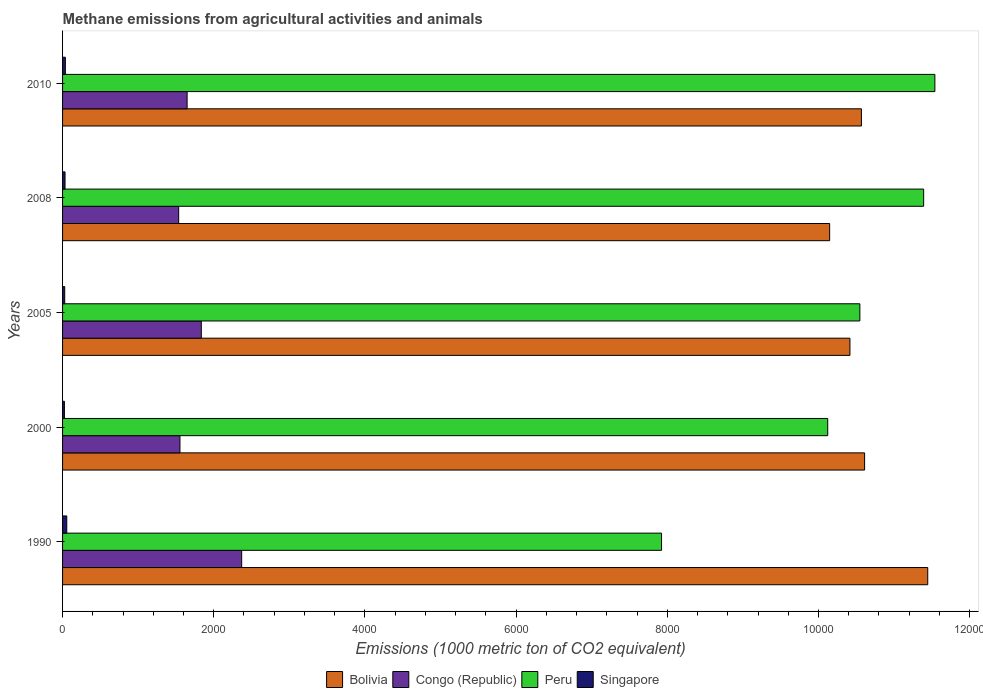How many different coloured bars are there?
Ensure brevity in your answer.  4. How many groups of bars are there?
Offer a very short reply. 5. How many bars are there on the 5th tick from the top?
Offer a terse response. 4. What is the label of the 5th group of bars from the top?
Keep it short and to the point. 1990. In how many cases, is the number of bars for a given year not equal to the number of legend labels?
Offer a very short reply. 0. What is the amount of methane emitted in Peru in 2000?
Offer a very short reply. 1.01e+04. Across all years, what is the maximum amount of methane emitted in Singapore?
Your answer should be very brief. 55.6. Across all years, what is the minimum amount of methane emitted in Singapore?
Offer a very short reply. 24.4. In which year was the amount of methane emitted in Congo (Republic) minimum?
Your response must be concise. 2008. What is the total amount of methane emitted in Singapore in the graph?
Keep it short and to the point. 178.1. What is the difference between the amount of methane emitted in Singapore in 1990 and that in 2000?
Your answer should be very brief. 31.2. What is the difference between the amount of methane emitted in Congo (Republic) in 2010 and the amount of methane emitted in Singapore in 2000?
Give a very brief answer. 1623.2. What is the average amount of methane emitted in Bolivia per year?
Keep it short and to the point. 1.06e+04. In the year 2010, what is the difference between the amount of methane emitted in Peru and amount of methane emitted in Congo (Republic)?
Your answer should be very brief. 9891.8. In how many years, is the amount of methane emitted in Peru greater than 2000 1000 metric ton?
Ensure brevity in your answer.  5. What is the ratio of the amount of methane emitted in Singapore in 2005 to that in 2010?
Keep it short and to the point. 0.77. Is the amount of methane emitted in Singapore in 1990 less than that in 2010?
Your answer should be very brief. No. Is the difference between the amount of methane emitted in Peru in 2000 and 2005 greater than the difference between the amount of methane emitted in Congo (Republic) in 2000 and 2005?
Ensure brevity in your answer.  No. What is the difference between the highest and the second highest amount of methane emitted in Peru?
Ensure brevity in your answer.  148.4. What is the difference between the highest and the lowest amount of methane emitted in Peru?
Ensure brevity in your answer.  3615.7. In how many years, is the amount of methane emitted in Peru greater than the average amount of methane emitted in Peru taken over all years?
Offer a very short reply. 3. Is the sum of the amount of methane emitted in Peru in 2005 and 2008 greater than the maximum amount of methane emitted in Singapore across all years?
Provide a succinct answer. Yes. Is it the case that in every year, the sum of the amount of methane emitted in Congo (Republic) and amount of methane emitted in Singapore is greater than the sum of amount of methane emitted in Peru and amount of methane emitted in Bolivia?
Your answer should be compact. No. What does the 1st bar from the top in 2010 represents?
Offer a very short reply. Singapore. What does the 2nd bar from the bottom in 2000 represents?
Offer a very short reply. Congo (Republic). Is it the case that in every year, the sum of the amount of methane emitted in Singapore and amount of methane emitted in Bolivia is greater than the amount of methane emitted in Peru?
Your answer should be very brief. No. How many bars are there?
Offer a very short reply. 20. Are all the bars in the graph horizontal?
Keep it short and to the point. Yes. Does the graph contain any zero values?
Provide a succinct answer. No. Does the graph contain grids?
Your response must be concise. No. Where does the legend appear in the graph?
Provide a short and direct response. Bottom center. How are the legend labels stacked?
Offer a very short reply. Horizontal. What is the title of the graph?
Provide a succinct answer. Methane emissions from agricultural activities and animals. What is the label or title of the X-axis?
Offer a very short reply. Emissions (1000 metric ton of CO2 equivalent). What is the Emissions (1000 metric ton of CO2 equivalent) in Bolivia in 1990?
Your answer should be compact. 1.14e+04. What is the Emissions (1000 metric ton of CO2 equivalent) in Congo (Republic) in 1990?
Your response must be concise. 2369.4. What is the Emissions (1000 metric ton of CO2 equivalent) in Peru in 1990?
Offer a terse response. 7923.7. What is the Emissions (1000 metric ton of CO2 equivalent) in Singapore in 1990?
Offer a very short reply. 55.6. What is the Emissions (1000 metric ton of CO2 equivalent) in Bolivia in 2000?
Give a very brief answer. 1.06e+04. What is the Emissions (1000 metric ton of CO2 equivalent) of Congo (Republic) in 2000?
Ensure brevity in your answer.  1552.9. What is the Emissions (1000 metric ton of CO2 equivalent) in Peru in 2000?
Provide a succinct answer. 1.01e+04. What is the Emissions (1000 metric ton of CO2 equivalent) in Singapore in 2000?
Provide a short and direct response. 24.4. What is the Emissions (1000 metric ton of CO2 equivalent) of Bolivia in 2005?
Offer a terse response. 1.04e+04. What is the Emissions (1000 metric ton of CO2 equivalent) of Congo (Republic) in 2005?
Your response must be concise. 1835.4. What is the Emissions (1000 metric ton of CO2 equivalent) of Peru in 2005?
Give a very brief answer. 1.05e+04. What is the Emissions (1000 metric ton of CO2 equivalent) in Singapore in 2005?
Your response must be concise. 28.4. What is the Emissions (1000 metric ton of CO2 equivalent) of Bolivia in 2008?
Offer a very short reply. 1.01e+04. What is the Emissions (1000 metric ton of CO2 equivalent) of Congo (Republic) in 2008?
Offer a very short reply. 1535.9. What is the Emissions (1000 metric ton of CO2 equivalent) in Peru in 2008?
Your answer should be compact. 1.14e+04. What is the Emissions (1000 metric ton of CO2 equivalent) of Singapore in 2008?
Keep it short and to the point. 32.8. What is the Emissions (1000 metric ton of CO2 equivalent) of Bolivia in 2010?
Your answer should be very brief. 1.06e+04. What is the Emissions (1000 metric ton of CO2 equivalent) in Congo (Republic) in 2010?
Provide a succinct answer. 1647.6. What is the Emissions (1000 metric ton of CO2 equivalent) in Peru in 2010?
Ensure brevity in your answer.  1.15e+04. What is the Emissions (1000 metric ton of CO2 equivalent) in Singapore in 2010?
Make the answer very short. 36.9. Across all years, what is the maximum Emissions (1000 metric ton of CO2 equivalent) in Bolivia?
Your response must be concise. 1.14e+04. Across all years, what is the maximum Emissions (1000 metric ton of CO2 equivalent) of Congo (Republic)?
Keep it short and to the point. 2369.4. Across all years, what is the maximum Emissions (1000 metric ton of CO2 equivalent) of Peru?
Provide a short and direct response. 1.15e+04. Across all years, what is the maximum Emissions (1000 metric ton of CO2 equivalent) of Singapore?
Keep it short and to the point. 55.6. Across all years, what is the minimum Emissions (1000 metric ton of CO2 equivalent) of Bolivia?
Your answer should be compact. 1.01e+04. Across all years, what is the minimum Emissions (1000 metric ton of CO2 equivalent) in Congo (Republic)?
Ensure brevity in your answer.  1535.9. Across all years, what is the minimum Emissions (1000 metric ton of CO2 equivalent) in Peru?
Offer a very short reply. 7923.7. Across all years, what is the minimum Emissions (1000 metric ton of CO2 equivalent) in Singapore?
Give a very brief answer. 24.4. What is the total Emissions (1000 metric ton of CO2 equivalent) of Bolivia in the graph?
Give a very brief answer. 5.32e+04. What is the total Emissions (1000 metric ton of CO2 equivalent) of Congo (Republic) in the graph?
Keep it short and to the point. 8941.2. What is the total Emissions (1000 metric ton of CO2 equivalent) of Peru in the graph?
Offer a very short reply. 5.15e+04. What is the total Emissions (1000 metric ton of CO2 equivalent) in Singapore in the graph?
Your answer should be compact. 178.1. What is the difference between the Emissions (1000 metric ton of CO2 equivalent) of Bolivia in 1990 and that in 2000?
Keep it short and to the point. 835.3. What is the difference between the Emissions (1000 metric ton of CO2 equivalent) in Congo (Republic) in 1990 and that in 2000?
Your answer should be compact. 816.5. What is the difference between the Emissions (1000 metric ton of CO2 equivalent) of Peru in 1990 and that in 2000?
Offer a very short reply. -2198.2. What is the difference between the Emissions (1000 metric ton of CO2 equivalent) in Singapore in 1990 and that in 2000?
Offer a very short reply. 31.2. What is the difference between the Emissions (1000 metric ton of CO2 equivalent) in Bolivia in 1990 and that in 2005?
Your answer should be compact. 1029.2. What is the difference between the Emissions (1000 metric ton of CO2 equivalent) of Congo (Republic) in 1990 and that in 2005?
Give a very brief answer. 534. What is the difference between the Emissions (1000 metric ton of CO2 equivalent) in Peru in 1990 and that in 2005?
Give a very brief answer. -2623.4. What is the difference between the Emissions (1000 metric ton of CO2 equivalent) in Singapore in 1990 and that in 2005?
Keep it short and to the point. 27.2. What is the difference between the Emissions (1000 metric ton of CO2 equivalent) in Bolivia in 1990 and that in 2008?
Make the answer very short. 1297.5. What is the difference between the Emissions (1000 metric ton of CO2 equivalent) in Congo (Republic) in 1990 and that in 2008?
Provide a short and direct response. 833.5. What is the difference between the Emissions (1000 metric ton of CO2 equivalent) of Peru in 1990 and that in 2008?
Provide a short and direct response. -3467.3. What is the difference between the Emissions (1000 metric ton of CO2 equivalent) of Singapore in 1990 and that in 2008?
Ensure brevity in your answer.  22.8. What is the difference between the Emissions (1000 metric ton of CO2 equivalent) in Bolivia in 1990 and that in 2010?
Provide a short and direct response. 877.3. What is the difference between the Emissions (1000 metric ton of CO2 equivalent) in Congo (Republic) in 1990 and that in 2010?
Provide a succinct answer. 721.8. What is the difference between the Emissions (1000 metric ton of CO2 equivalent) of Peru in 1990 and that in 2010?
Your answer should be compact. -3615.7. What is the difference between the Emissions (1000 metric ton of CO2 equivalent) of Singapore in 1990 and that in 2010?
Provide a short and direct response. 18.7. What is the difference between the Emissions (1000 metric ton of CO2 equivalent) in Bolivia in 2000 and that in 2005?
Your answer should be compact. 193.9. What is the difference between the Emissions (1000 metric ton of CO2 equivalent) of Congo (Republic) in 2000 and that in 2005?
Keep it short and to the point. -282.5. What is the difference between the Emissions (1000 metric ton of CO2 equivalent) of Peru in 2000 and that in 2005?
Provide a short and direct response. -425.2. What is the difference between the Emissions (1000 metric ton of CO2 equivalent) in Bolivia in 2000 and that in 2008?
Your answer should be compact. 462.2. What is the difference between the Emissions (1000 metric ton of CO2 equivalent) of Peru in 2000 and that in 2008?
Provide a short and direct response. -1269.1. What is the difference between the Emissions (1000 metric ton of CO2 equivalent) of Bolivia in 2000 and that in 2010?
Your answer should be compact. 42. What is the difference between the Emissions (1000 metric ton of CO2 equivalent) of Congo (Republic) in 2000 and that in 2010?
Your response must be concise. -94.7. What is the difference between the Emissions (1000 metric ton of CO2 equivalent) of Peru in 2000 and that in 2010?
Your answer should be very brief. -1417.5. What is the difference between the Emissions (1000 metric ton of CO2 equivalent) in Bolivia in 2005 and that in 2008?
Provide a short and direct response. 268.3. What is the difference between the Emissions (1000 metric ton of CO2 equivalent) of Congo (Republic) in 2005 and that in 2008?
Keep it short and to the point. 299.5. What is the difference between the Emissions (1000 metric ton of CO2 equivalent) of Peru in 2005 and that in 2008?
Offer a terse response. -843.9. What is the difference between the Emissions (1000 metric ton of CO2 equivalent) of Bolivia in 2005 and that in 2010?
Make the answer very short. -151.9. What is the difference between the Emissions (1000 metric ton of CO2 equivalent) of Congo (Republic) in 2005 and that in 2010?
Your response must be concise. 187.8. What is the difference between the Emissions (1000 metric ton of CO2 equivalent) of Peru in 2005 and that in 2010?
Provide a short and direct response. -992.3. What is the difference between the Emissions (1000 metric ton of CO2 equivalent) of Singapore in 2005 and that in 2010?
Ensure brevity in your answer.  -8.5. What is the difference between the Emissions (1000 metric ton of CO2 equivalent) in Bolivia in 2008 and that in 2010?
Make the answer very short. -420.2. What is the difference between the Emissions (1000 metric ton of CO2 equivalent) of Congo (Republic) in 2008 and that in 2010?
Keep it short and to the point. -111.7. What is the difference between the Emissions (1000 metric ton of CO2 equivalent) of Peru in 2008 and that in 2010?
Your answer should be compact. -148.4. What is the difference between the Emissions (1000 metric ton of CO2 equivalent) in Bolivia in 1990 and the Emissions (1000 metric ton of CO2 equivalent) in Congo (Republic) in 2000?
Provide a succinct answer. 9892.1. What is the difference between the Emissions (1000 metric ton of CO2 equivalent) in Bolivia in 1990 and the Emissions (1000 metric ton of CO2 equivalent) in Peru in 2000?
Offer a terse response. 1323.1. What is the difference between the Emissions (1000 metric ton of CO2 equivalent) of Bolivia in 1990 and the Emissions (1000 metric ton of CO2 equivalent) of Singapore in 2000?
Give a very brief answer. 1.14e+04. What is the difference between the Emissions (1000 metric ton of CO2 equivalent) of Congo (Republic) in 1990 and the Emissions (1000 metric ton of CO2 equivalent) of Peru in 2000?
Offer a terse response. -7752.5. What is the difference between the Emissions (1000 metric ton of CO2 equivalent) of Congo (Republic) in 1990 and the Emissions (1000 metric ton of CO2 equivalent) of Singapore in 2000?
Offer a terse response. 2345. What is the difference between the Emissions (1000 metric ton of CO2 equivalent) in Peru in 1990 and the Emissions (1000 metric ton of CO2 equivalent) in Singapore in 2000?
Offer a very short reply. 7899.3. What is the difference between the Emissions (1000 metric ton of CO2 equivalent) of Bolivia in 1990 and the Emissions (1000 metric ton of CO2 equivalent) of Congo (Republic) in 2005?
Your answer should be compact. 9609.6. What is the difference between the Emissions (1000 metric ton of CO2 equivalent) of Bolivia in 1990 and the Emissions (1000 metric ton of CO2 equivalent) of Peru in 2005?
Your answer should be compact. 897.9. What is the difference between the Emissions (1000 metric ton of CO2 equivalent) in Bolivia in 1990 and the Emissions (1000 metric ton of CO2 equivalent) in Singapore in 2005?
Offer a very short reply. 1.14e+04. What is the difference between the Emissions (1000 metric ton of CO2 equivalent) in Congo (Republic) in 1990 and the Emissions (1000 metric ton of CO2 equivalent) in Peru in 2005?
Your answer should be very brief. -8177.7. What is the difference between the Emissions (1000 metric ton of CO2 equivalent) in Congo (Republic) in 1990 and the Emissions (1000 metric ton of CO2 equivalent) in Singapore in 2005?
Your answer should be compact. 2341. What is the difference between the Emissions (1000 metric ton of CO2 equivalent) of Peru in 1990 and the Emissions (1000 metric ton of CO2 equivalent) of Singapore in 2005?
Your answer should be compact. 7895.3. What is the difference between the Emissions (1000 metric ton of CO2 equivalent) of Bolivia in 1990 and the Emissions (1000 metric ton of CO2 equivalent) of Congo (Republic) in 2008?
Give a very brief answer. 9909.1. What is the difference between the Emissions (1000 metric ton of CO2 equivalent) in Bolivia in 1990 and the Emissions (1000 metric ton of CO2 equivalent) in Singapore in 2008?
Your answer should be very brief. 1.14e+04. What is the difference between the Emissions (1000 metric ton of CO2 equivalent) in Congo (Republic) in 1990 and the Emissions (1000 metric ton of CO2 equivalent) in Peru in 2008?
Keep it short and to the point. -9021.6. What is the difference between the Emissions (1000 metric ton of CO2 equivalent) in Congo (Republic) in 1990 and the Emissions (1000 metric ton of CO2 equivalent) in Singapore in 2008?
Offer a terse response. 2336.6. What is the difference between the Emissions (1000 metric ton of CO2 equivalent) in Peru in 1990 and the Emissions (1000 metric ton of CO2 equivalent) in Singapore in 2008?
Give a very brief answer. 7890.9. What is the difference between the Emissions (1000 metric ton of CO2 equivalent) in Bolivia in 1990 and the Emissions (1000 metric ton of CO2 equivalent) in Congo (Republic) in 2010?
Offer a terse response. 9797.4. What is the difference between the Emissions (1000 metric ton of CO2 equivalent) of Bolivia in 1990 and the Emissions (1000 metric ton of CO2 equivalent) of Peru in 2010?
Your answer should be compact. -94.4. What is the difference between the Emissions (1000 metric ton of CO2 equivalent) of Bolivia in 1990 and the Emissions (1000 metric ton of CO2 equivalent) of Singapore in 2010?
Ensure brevity in your answer.  1.14e+04. What is the difference between the Emissions (1000 metric ton of CO2 equivalent) of Congo (Republic) in 1990 and the Emissions (1000 metric ton of CO2 equivalent) of Peru in 2010?
Make the answer very short. -9170. What is the difference between the Emissions (1000 metric ton of CO2 equivalent) of Congo (Republic) in 1990 and the Emissions (1000 metric ton of CO2 equivalent) of Singapore in 2010?
Give a very brief answer. 2332.5. What is the difference between the Emissions (1000 metric ton of CO2 equivalent) in Peru in 1990 and the Emissions (1000 metric ton of CO2 equivalent) in Singapore in 2010?
Give a very brief answer. 7886.8. What is the difference between the Emissions (1000 metric ton of CO2 equivalent) in Bolivia in 2000 and the Emissions (1000 metric ton of CO2 equivalent) in Congo (Republic) in 2005?
Keep it short and to the point. 8774.3. What is the difference between the Emissions (1000 metric ton of CO2 equivalent) of Bolivia in 2000 and the Emissions (1000 metric ton of CO2 equivalent) of Peru in 2005?
Give a very brief answer. 62.6. What is the difference between the Emissions (1000 metric ton of CO2 equivalent) in Bolivia in 2000 and the Emissions (1000 metric ton of CO2 equivalent) in Singapore in 2005?
Offer a terse response. 1.06e+04. What is the difference between the Emissions (1000 metric ton of CO2 equivalent) of Congo (Republic) in 2000 and the Emissions (1000 metric ton of CO2 equivalent) of Peru in 2005?
Keep it short and to the point. -8994.2. What is the difference between the Emissions (1000 metric ton of CO2 equivalent) of Congo (Republic) in 2000 and the Emissions (1000 metric ton of CO2 equivalent) of Singapore in 2005?
Your response must be concise. 1524.5. What is the difference between the Emissions (1000 metric ton of CO2 equivalent) of Peru in 2000 and the Emissions (1000 metric ton of CO2 equivalent) of Singapore in 2005?
Your response must be concise. 1.01e+04. What is the difference between the Emissions (1000 metric ton of CO2 equivalent) in Bolivia in 2000 and the Emissions (1000 metric ton of CO2 equivalent) in Congo (Republic) in 2008?
Your answer should be very brief. 9073.8. What is the difference between the Emissions (1000 metric ton of CO2 equivalent) of Bolivia in 2000 and the Emissions (1000 metric ton of CO2 equivalent) of Peru in 2008?
Provide a succinct answer. -781.3. What is the difference between the Emissions (1000 metric ton of CO2 equivalent) of Bolivia in 2000 and the Emissions (1000 metric ton of CO2 equivalent) of Singapore in 2008?
Offer a terse response. 1.06e+04. What is the difference between the Emissions (1000 metric ton of CO2 equivalent) of Congo (Republic) in 2000 and the Emissions (1000 metric ton of CO2 equivalent) of Peru in 2008?
Make the answer very short. -9838.1. What is the difference between the Emissions (1000 metric ton of CO2 equivalent) in Congo (Republic) in 2000 and the Emissions (1000 metric ton of CO2 equivalent) in Singapore in 2008?
Keep it short and to the point. 1520.1. What is the difference between the Emissions (1000 metric ton of CO2 equivalent) in Peru in 2000 and the Emissions (1000 metric ton of CO2 equivalent) in Singapore in 2008?
Provide a short and direct response. 1.01e+04. What is the difference between the Emissions (1000 metric ton of CO2 equivalent) of Bolivia in 2000 and the Emissions (1000 metric ton of CO2 equivalent) of Congo (Republic) in 2010?
Provide a succinct answer. 8962.1. What is the difference between the Emissions (1000 metric ton of CO2 equivalent) of Bolivia in 2000 and the Emissions (1000 metric ton of CO2 equivalent) of Peru in 2010?
Your answer should be very brief. -929.7. What is the difference between the Emissions (1000 metric ton of CO2 equivalent) of Bolivia in 2000 and the Emissions (1000 metric ton of CO2 equivalent) of Singapore in 2010?
Your answer should be very brief. 1.06e+04. What is the difference between the Emissions (1000 metric ton of CO2 equivalent) in Congo (Republic) in 2000 and the Emissions (1000 metric ton of CO2 equivalent) in Peru in 2010?
Offer a very short reply. -9986.5. What is the difference between the Emissions (1000 metric ton of CO2 equivalent) of Congo (Republic) in 2000 and the Emissions (1000 metric ton of CO2 equivalent) of Singapore in 2010?
Provide a short and direct response. 1516. What is the difference between the Emissions (1000 metric ton of CO2 equivalent) of Peru in 2000 and the Emissions (1000 metric ton of CO2 equivalent) of Singapore in 2010?
Offer a very short reply. 1.01e+04. What is the difference between the Emissions (1000 metric ton of CO2 equivalent) in Bolivia in 2005 and the Emissions (1000 metric ton of CO2 equivalent) in Congo (Republic) in 2008?
Your response must be concise. 8879.9. What is the difference between the Emissions (1000 metric ton of CO2 equivalent) in Bolivia in 2005 and the Emissions (1000 metric ton of CO2 equivalent) in Peru in 2008?
Provide a succinct answer. -975.2. What is the difference between the Emissions (1000 metric ton of CO2 equivalent) in Bolivia in 2005 and the Emissions (1000 metric ton of CO2 equivalent) in Singapore in 2008?
Ensure brevity in your answer.  1.04e+04. What is the difference between the Emissions (1000 metric ton of CO2 equivalent) in Congo (Republic) in 2005 and the Emissions (1000 metric ton of CO2 equivalent) in Peru in 2008?
Keep it short and to the point. -9555.6. What is the difference between the Emissions (1000 metric ton of CO2 equivalent) of Congo (Republic) in 2005 and the Emissions (1000 metric ton of CO2 equivalent) of Singapore in 2008?
Provide a short and direct response. 1802.6. What is the difference between the Emissions (1000 metric ton of CO2 equivalent) in Peru in 2005 and the Emissions (1000 metric ton of CO2 equivalent) in Singapore in 2008?
Your answer should be compact. 1.05e+04. What is the difference between the Emissions (1000 metric ton of CO2 equivalent) in Bolivia in 2005 and the Emissions (1000 metric ton of CO2 equivalent) in Congo (Republic) in 2010?
Keep it short and to the point. 8768.2. What is the difference between the Emissions (1000 metric ton of CO2 equivalent) of Bolivia in 2005 and the Emissions (1000 metric ton of CO2 equivalent) of Peru in 2010?
Keep it short and to the point. -1123.6. What is the difference between the Emissions (1000 metric ton of CO2 equivalent) of Bolivia in 2005 and the Emissions (1000 metric ton of CO2 equivalent) of Singapore in 2010?
Ensure brevity in your answer.  1.04e+04. What is the difference between the Emissions (1000 metric ton of CO2 equivalent) of Congo (Republic) in 2005 and the Emissions (1000 metric ton of CO2 equivalent) of Peru in 2010?
Offer a terse response. -9704. What is the difference between the Emissions (1000 metric ton of CO2 equivalent) of Congo (Republic) in 2005 and the Emissions (1000 metric ton of CO2 equivalent) of Singapore in 2010?
Give a very brief answer. 1798.5. What is the difference between the Emissions (1000 metric ton of CO2 equivalent) of Peru in 2005 and the Emissions (1000 metric ton of CO2 equivalent) of Singapore in 2010?
Your response must be concise. 1.05e+04. What is the difference between the Emissions (1000 metric ton of CO2 equivalent) of Bolivia in 2008 and the Emissions (1000 metric ton of CO2 equivalent) of Congo (Republic) in 2010?
Give a very brief answer. 8499.9. What is the difference between the Emissions (1000 metric ton of CO2 equivalent) in Bolivia in 2008 and the Emissions (1000 metric ton of CO2 equivalent) in Peru in 2010?
Offer a very short reply. -1391.9. What is the difference between the Emissions (1000 metric ton of CO2 equivalent) of Bolivia in 2008 and the Emissions (1000 metric ton of CO2 equivalent) of Singapore in 2010?
Provide a succinct answer. 1.01e+04. What is the difference between the Emissions (1000 metric ton of CO2 equivalent) in Congo (Republic) in 2008 and the Emissions (1000 metric ton of CO2 equivalent) in Peru in 2010?
Provide a short and direct response. -1.00e+04. What is the difference between the Emissions (1000 metric ton of CO2 equivalent) of Congo (Republic) in 2008 and the Emissions (1000 metric ton of CO2 equivalent) of Singapore in 2010?
Make the answer very short. 1499. What is the difference between the Emissions (1000 metric ton of CO2 equivalent) in Peru in 2008 and the Emissions (1000 metric ton of CO2 equivalent) in Singapore in 2010?
Provide a succinct answer. 1.14e+04. What is the average Emissions (1000 metric ton of CO2 equivalent) of Bolivia per year?
Your answer should be very brief. 1.06e+04. What is the average Emissions (1000 metric ton of CO2 equivalent) of Congo (Republic) per year?
Make the answer very short. 1788.24. What is the average Emissions (1000 metric ton of CO2 equivalent) of Peru per year?
Provide a succinct answer. 1.03e+04. What is the average Emissions (1000 metric ton of CO2 equivalent) in Singapore per year?
Offer a very short reply. 35.62. In the year 1990, what is the difference between the Emissions (1000 metric ton of CO2 equivalent) of Bolivia and Emissions (1000 metric ton of CO2 equivalent) of Congo (Republic)?
Provide a short and direct response. 9075.6. In the year 1990, what is the difference between the Emissions (1000 metric ton of CO2 equivalent) in Bolivia and Emissions (1000 metric ton of CO2 equivalent) in Peru?
Provide a short and direct response. 3521.3. In the year 1990, what is the difference between the Emissions (1000 metric ton of CO2 equivalent) in Bolivia and Emissions (1000 metric ton of CO2 equivalent) in Singapore?
Your answer should be compact. 1.14e+04. In the year 1990, what is the difference between the Emissions (1000 metric ton of CO2 equivalent) of Congo (Republic) and Emissions (1000 metric ton of CO2 equivalent) of Peru?
Provide a short and direct response. -5554.3. In the year 1990, what is the difference between the Emissions (1000 metric ton of CO2 equivalent) of Congo (Republic) and Emissions (1000 metric ton of CO2 equivalent) of Singapore?
Provide a short and direct response. 2313.8. In the year 1990, what is the difference between the Emissions (1000 metric ton of CO2 equivalent) of Peru and Emissions (1000 metric ton of CO2 equivalent) of Singapore?
Give a very brief answer. 7868.1. In the year 2000, what is the difference between the Emissions (1000 metric ton of CO2 equivalent) in Bolivia and Emissions (1000 metric ton of CO2 equivalent) in Congo (Republic)?
Offer a very short reply. 9056.8. In the year 2000, what is the difference between the Emissions (1000 metric ton of CO2 equivalent) in Bolivia and Emissions (1000 metric ton of CO2 equivalent) in Peru?
Offer a very short reply. 487.8. In the year 2000, what is the difference between the Emissions (1000 metric ton of CO2 equivalent) in Bolivia and Emissions (1000 metric ton of CO2 equivalent) in Singapore?
Your response must be concise. 1.06e+04. In the year 2000, what is the difference between the Emissions (1000 metric ton of CO2 equivalent) of Congo (Republic) and Emissions (1000 metric ton of CO2 equivalent) of Peru?
Your answer should be compact. -8569. In the year 2000, what is the difference between the Emissions (1000 metric ton of CO2 equivalent) of Congo (Republic) and Emissions (1000 metric ton of CO2 equivalent) of Singapore?
Offer a terse response. 1528.5. In the year 2000, what is the difference between the Emissions (1000 metric ton of CO2 equivalent) in Peru and Emissions (1000 metric ton of CO2 equivalent) in Singapore?
Give a very brief answer. 1.01e+04. In the year 2005, what is the difference between the Emissions (1000 metric ton of CO2 equivalent) in Bolivia and Emissions (1000 metric ton of CO2 equivalent) in Congo (Republic)?
Provide a succinct answer. 8580.4. In the year 2005, what is the difference between the Emissions (1000 metric ton of CO2 equivalent) in Bolivia and Emissions (1000 metric ton of CO2 equivalent) in Peru?
Keep it short and to the point. -131.3. In the year 2005, what is the difference between the Emissions (1000 metric ton of CO2 equivalent) of Bolivia and Emissions (1000 metric ton of CO2 equivalent) of Singapore?
Provide a short and direct response. 1.04e+04. In the year 2005, what is the difference between the Emissions (1000 metric ton of CO2 equivalent) of Congo (Republic) and Emissions (1000 metric ton of CO2 equivalent) of Peru?
Give a very brief answer. -8711.7. In the year 2005, what is the difference between the Emissions (1000 metric ton of CO2 equivalent) of Congo (Republic) and Emissions (1000 metric ton of CO2 equivalent) of Singapore?
Keep it short and to the point. 1807. In the year 2005, what is the difference between the Emissions (1000 metric ton of CO2 equivalent) of Peru and Emissions (1000 metric ton of CO2 equivalent) of Singapore?
Provide a succinct answer. 1.05e+04. In the year 2008, what is the difference between the Emissions (1000 metric ton of CO2 equivalent) of Bolivia and Emissions (1000 metric ton of CO2 equivalent) of Congo (Republic)?
Offer a terse response. 8611.6. In the year 2008, what is the difference between the Emissions (1000 metric ton of CO2 equivalent) in Bolivia and Emissions (1000 metric ton of CO2 equivalent) in Peru?
Your answer should be very brief. -1243.5. In the year 2008, what is the difference between the Emissions (1000 metric ton of CO2 equivalent) of Bolivia and Emissions (1000 metric ton of CO2 equivalent) of Singapore?
Your answer should be compact. 1.01e+04. In the year 2008, what is the difference between the Emissions (1000 metric ton of CO2 equivalent) of Congo (Republic) and Emissions (1000 metric ton of CO2 equivalent) of Peru?
Offer a terse response. -9855.1. In the year 2008, what is the difference between the Emissions (1000 metric ton of CO2 equivalent) in Congo (Republic) and Emissions (1000 metric ton of CO2 equivalent) in Singapore?
Your response must be concise. 1503.1. In the year 2008, what is the difference between the Emissions (1000 metric ton of CO2 equivalent) in Peru and Emissions (1000 metric ton of CO2 equivalent) in Singapore?
Offer a terse response. 1.14e+04. In the year 2010, what is the difference between the Emissions (1000 metric ton of CO2 equivalent) of Bolivia and Emissions (1000 metric ton of CO2 equivalent) of Congo (Republic)?
Offer a very short reply. 8920.1. In the year 2010, what is the difference between the Emissions (1000 metric ton of CO2 equivalent) in Bolivia and Emissions (1000 metric ton of CO2 equivalent) in Peru?
Your answer should be very brief. -971.7. In the year 2010, what is the difference between the Emissions (1000 metric ton of CO2 equivalent) of Bolivia and Emissions (1000 metric ton of CO2 equivalent) of Singapore?
Keep it short and to the point. 1.05e+04. In the year 2010, what is the difference between the Emissions (1000 metric ton of CO2 equivalent) of Congo (Republic) and Emissions (1000 metric ton of CO2 equivalent) of Peru?
Offer a terse response. -9891.8. In the year 2010, what is the difference between the Emissions (1000 metric ton of CO2 equivalent) in Congo (Republic) and Emissions (1000 metric ton of CO2 equivalent) in Singapore?
Make the answer very short. 1610.7. In the year 2010, what is the difference between the Emissions (1000 metric ton of CO2 equivalent) of Peru and Emissions (1000 metric ton of CO2 equivalent) of Singapore?
Offer a terse response. 1.15e+04. What is the ratio of the Emissions (1000 metric ton of CO2 equivalent) of Bolivia in 1990 to that in 2000?
Offer a terse response. 1.08. What is the ratio of the Emissions (1000 metric ton of CO2 equivalent) of Congo (Republic) in 1990 to that in 2000?
Your answer should be very brief. 1.53. What is the ratio of the Emissions (1000 metric ton of CO2 equivalent) in Peru in 1990 to that in 2000?
Provide a short and direct response. 0.78. What is the ratio of the Emissions (1000 metric ton of CO2 equivalent) of Singapore in 1990 to that in 2000?
Ensure brevity in your answer.  2.28. What is the ratio of the Emissions (1000 metric ton of CO2 equivalent) in Bolivia in 1990 to that in 2005?
Give a very brief answer. 1.1. What is the ratio of the Emissions (1000 metric ton of CO2 equivalent) in Congo (Republic) in 1990 to that in 2005?
Your answer should be very brief. 1.29. What is the ratio of the Emissions (1000 metric ton of CO2 equivalent) in Peru in 1990 to that in 2005?
Ensure brevity in your answer.  0.75. What is the ratio of the Emissions (1000 metric ton of CO2 equivalent) in Singapore in 1990 to that in 2005?
Provide a succinct answer. 1.96. What is the ratio of the Emissions (1000 metric ton of CO2 equivalent) in Bolivia in 1990 to that in 2008?
Your response must be concise. 1.13. What is the ratio of the Emissions (1000 metric ton of CO2 equivalent) in Congo (Republic) in 1990 to that in 2008?
Provide a short and direct response. 1.54. What is the ratio of the Emissions (1000 metric ton of CO2 equivalent) of Peru in 1990 to that in 2008?
Give a very brief answer. 0.7. What is the ratio of the Emissions (1000 metric ton of CO2 equivalent) in Singapore in 1990 to that in 2008?
Your answer should be compact. 1.7. What is the ratio of the Emissions (1000 metric ton of CO2 equivalent) in Bolivia in 1990 to that in 2010?
Provide a succinct answer. 1.08. What is the ratio of the Emissions (1000 metric ton of CO2 equivalent) in Congo (Republic) in 1990 to that in 2010?
Ensure brevity in your answer.  1.44. What is the ratio of the Emissions (1000 metric ton of CO2 equivalent) in Peru in 1990 to that in 2010?
Your answer should be compact. 0.69. What is the ratio of the Emissions (1000 metric ton of CO2 equivalent) in Singapore in 1990 to that in 2010?
Your response must be concise. 1.51. What is the ratio of the Emissions (1000 metric ton of CO2 equivalent) in Bolivia in 2000 to that in 2005?
Ensure brevity in your answer.  1.02. What is the ratio of the Emissions (1000 metric ton of CO2 equivalent) of Congo (Republic) in 2000 to that in 2005?
Ensure brevity in your answer.  0.85. What is the ratio of the Emissions (1000 metric ton of CO2 equivalent) in Peru in 2000 to that in 2005?
Your answer should be compact. 0.96. What is the ratio of the Emissions (1000 metric ton of CO2 equivalent) of Singapore in 2000 to that in 2005?
Offer a very short reply. 0.86. What is the ratio of the Emissions (1000 metric ton of CO2 equivalent) of Bolivia in 2000 to that in 2008?
Keep it short and to the point. 1.05. What is the ratio of the Emissions (1000 metric ton of CO2 equivalent) of Congo (Republic) in 2000 to that in 2008?
Offer a very short reply. 1.01. What is the ratio of the Emissions (1000 metric ton of CO2 equivalent) in Peru in 2000 to that in 2008?
Keep it short and to the point. 0.89. What is the ratio of the Emissions (1000 metric ton of CO2 equivalent) in Singapore in 2000 to that in 2008?
Provide a succinct answer. 0.74. What is the ratio of the Emissions (1000 metric ton of CO2 equivalent) in Bolivia in 2000 to that in 2010?
Offer a very short reply. 1. What is the ratio of the Emissions (1000 metric ton of CO2 equivalent) in Congo (Republic) in 2000 to that in 2010?
Offer a very short reply. 0.94. What is the ratio of the Emissions (1000 metric ton of CO2 equivalent) in Peru in 2000 to that in 2010?
Provide a short and direct response. 0.88. What is the ratio of the Emissions (1000 metric ton of CO2 equivalent) in Singapore in 2000 to that in 2010?
Provide a succinct answer. 0.66. What is the ratio of the Emissions (1000 metric ton of CO2 equivalent) of Bolivia in 2005 to that in 2008?
Your answer should be very brief. 1.03. What is the ratio of the Emissions (1000 metric ton of CO2 equivalent) of Congo (Republic) in 2005 to that in 2008?
Your response must be concise. 1.2. What is the ratio of the Emissions (1000 metric ton of CO2 equivalent) of Peru in 2005 to that in 2008?
Provide a short and direct response. 0.93. What is the ratio of the Emissions (1000 metric ton of CO2 equivalent) of Singapore in 2005 to that in 2008?
Provide a succinct answer. 0.87. What is the ratio of the Emissions (1000 metric ton of CO2 equivalent) of Bolivia in 2005 to that in 2010?
Your response must be concise. 0.99. What is the ratio of the Emissions (1000 metric ton of CO2 equivalent) of Congo (Republic) in 2005 to that in 2010?
Offer a very short reply. 1.11. What is the ratio of the Emissions (1000 metric ton of CO2 equivalent) in Peru in 2005 to that in 2010?
Offer a terse response. 0.91. What is the ratio of the Emissions (1000 metric ton of CO2 equivalent) in Singapore in 2005 to that in 2010?
Offer a very short reply. 0.77. What is the ratio of the Emissions (1000 metric ton of CO2 equivalent) in Bolivia in 2008 to that in 2010?
Provide a succinct answer. 0.96. What is the ratio of the Emissions (1000 metric ton of CO2 equivalent) in Congo (Republic) in 2008 to that in 2010?
Ensure brevity in your answer.  0.93. What is the ratio of the Emissions (1000 metric ton of CO2 equivalent) of Peru in 2008 to that in 2010?
Your answer should be compact. 0.99. What is the ratio of the Emissions (1000 metric ton of CO2 equivalent) in Singapore in 2008 to that in 2010?
Provide a short and direct response. 0.89. What is the difference between the highest and the second highest Emissions (1000 metric ton of CO2 equivalent) of Bolivia?
Your answer should be very brief. 835.3. What is the difference between the highest and the second highest Emissions (1000 metric ton of CO2 equivalent) of Congo (Republic)?
Your answer should be very brief. 534. What is the difference between the highest and the second highest Emissions (1000 metric ton of CO2 equivalent) of Peru?
Keep it short and to the point. 148.4. What is the difference between the highest and the lowest Emissions (1000 metric ton of CO2 equivalent) of Bolivia?
Offer a very short reply. 1297.5. What is the difference between the highest and the lowest Emissions (1000 metric ton of CO2 equivalent) in Congo (Republic)?
Keep it short and to the point. 833.5. What is the difference between the highest and the lowest Emissions (1000 metric ton of CO2 equivalent) in Peru?
Offer a terse response. 3615.7. What is the difference between the highest and the lowest Emissions (1000 metric ton of CO2 equivalent) of Singapore?
Your answer should be very brief. 31.2. 